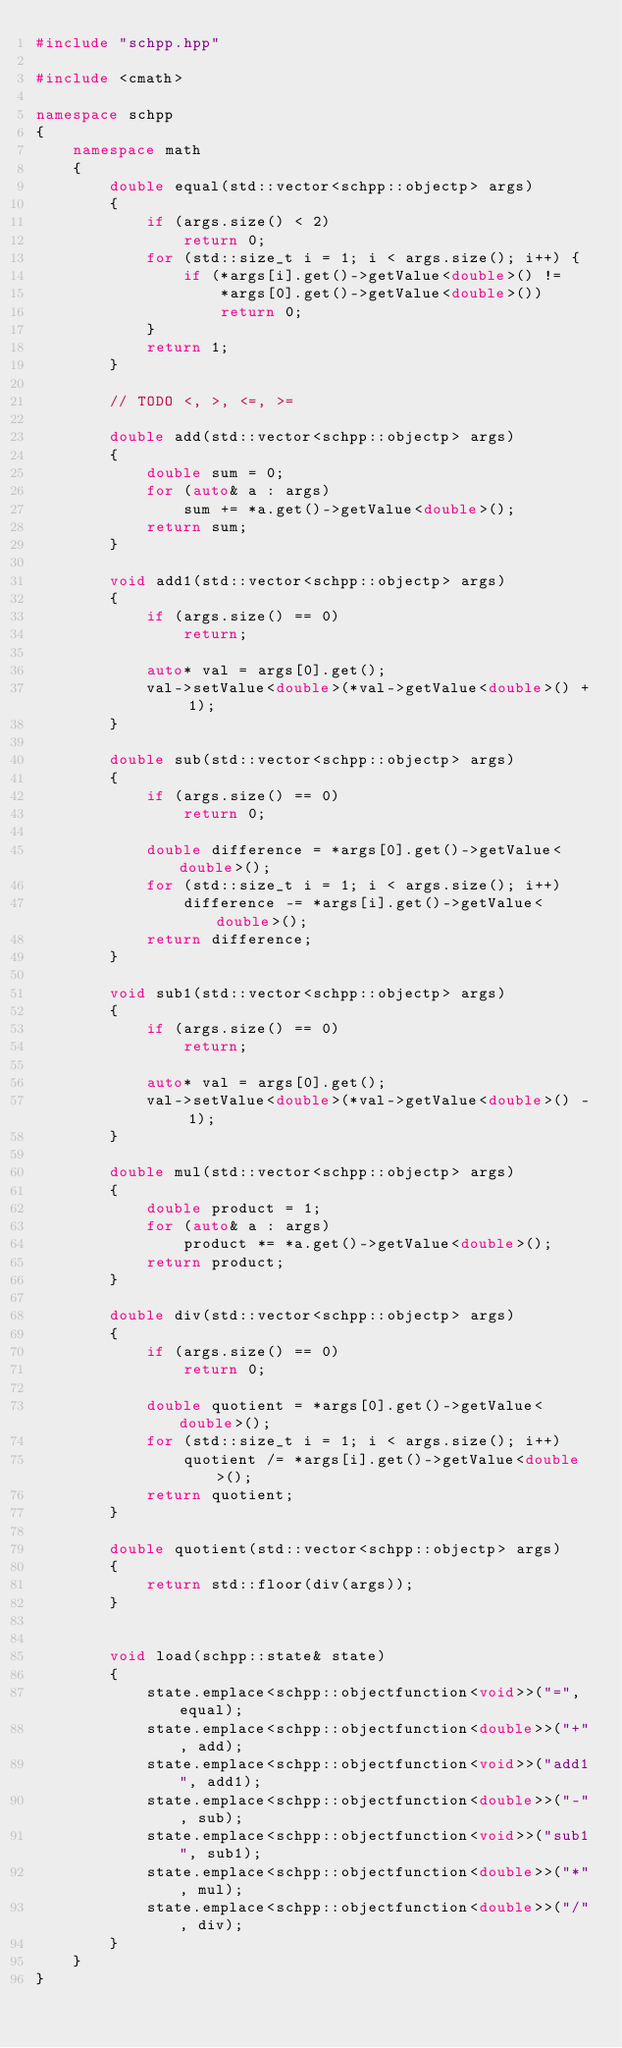<code> <loc_0><loc_0><loc_500><loc_500><_C++_>#include "schpp.hpp"

#include <cmath>

namespace schpp
{
    namespace math
    {
        double equal(std::vector<schpp::objectp> args)
        {
            if (args.size() < 2)
                return 0;
            for (std::size_t i = 1; i < args.size(); i++) {
                if (*args[i].get()->getValue<double>() !=
                    *args[0].get()->getValue<double>())
                    return 0;
            }
            return 1;
        }

        // TODO <, >, <=, >=

        double add(std::vector<schpp::objectp> args)
        {
            double sum = 0;
            for (auto& a : args)
                sum += *a.get()->getValue<double>();
            return sum;
        }

        void add1(std::vector<schpp::objectp> args)
        {
            if (args.size() == 0)
                return;
            
            auto* val = args[0].get();
            val->setValue<double>(*val->getValue<double>() + 1);
        }

        double sub(std::vector<schpp::objectp> args)
        {
            if (args.size() == 0)
                return 0;

            double difference = *args[0].get()->getValue<double>();
            for (std::size_t i = 1; i < args.size(); i++)
                difference -= *args[i].get()->getValue<double>();
            return difference;
        }

        void sub1(std::vector<schpp::objectp> args)
        {
            if (args.size() == 0)
                return;
            
            auto* val = args[0].get();
            val->setValue<double>(*val->getValue<double>() - 1);
        }

        double mul(std::vector<schpp::objectp> args)
        {
            double product = 1;
            for (auto& a : args)
                product *= *a.get()->getValue<double>();
            return product;
        }

        double div(std::vector<schpp::objectp> args)
        {
            if (args.size() == 0)
                return 0;

            double quotient = *args[0].get()->getValue<double>();
            for (std::size_t i = 1; i < args.size(); i++)
                quotient /= *args[i].get()->getValue<double>();
            return quotient;
        }

        double quotient(std::vector<schpp::objectp> args)
        {
            return std::floor(div(args));
        }


        void load(schpp::state& state)
        {
            state.emplace<schpp::objectfunction<void>>("=", equal);
            state.emplace<schpp::objectfunction<double>>("+", add);
            state.emplace<schpp::objectfunction<void>>("add1", add1);
            state.emplace<schpp::objectfunction<double>>("-", sub);
            state.emplace<schpp::objectfunction<void>>("sub1", sub1);
            state.emplace<schpp::objectfunction<double>>("*", mul);
            state.emplace<schpp::objectfunction<double>>("/", div);
        }
    }
}

</code> 